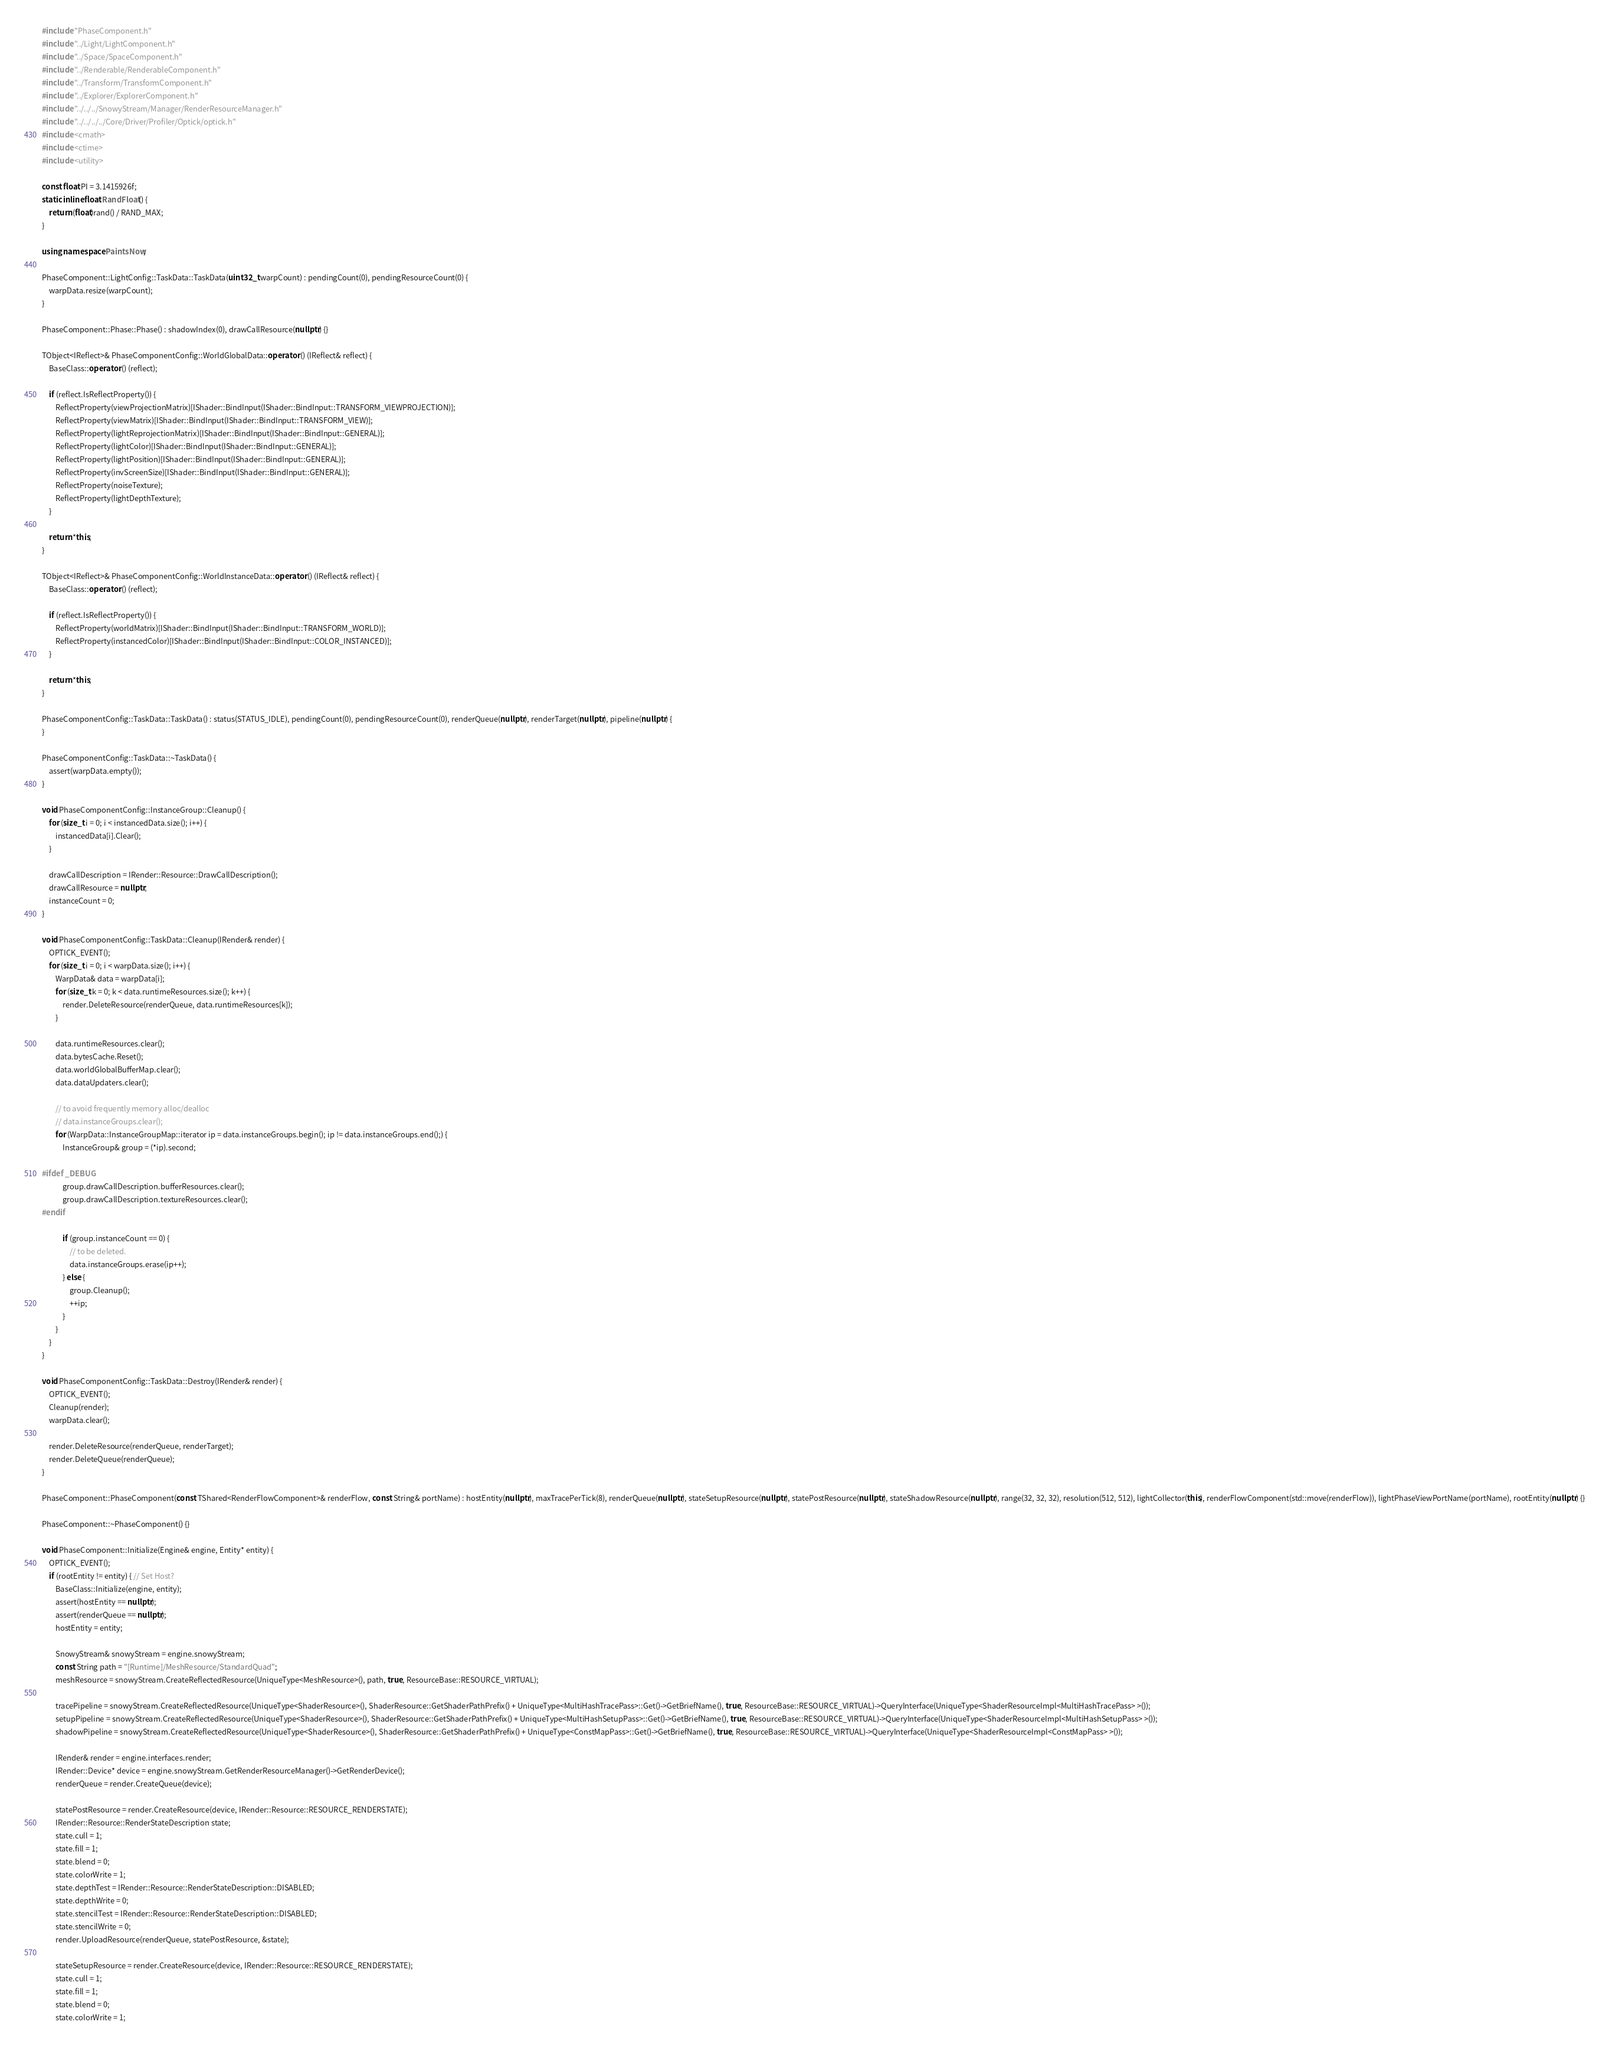Convert code to text. <code><loc_0><loc_0><loc_500><loc_500><_C++_>#include "PhaseComponent.h"
#include "../Light/LightComponent.h"
#include "../Space/SpaceComponent.h"
#include "../Renderable/RenderableComponent.h"
#include "../Transform/TransformComponent.h"
#include "../Explorer/ExplorerComponent.h"
#include "../../../SnowyStream/Manager/RenderResourceManager.h"
#include "../../../../Core/Driver/Profiler/Optick/optick.h"
#include <cmath>
#include <ctime>
#include <utility>

const float PI = 3.1415926f;
static inline float RandFloat() {
	return (float)rand() / RAND_MAX;
}

using namespace PaintsNow;

PhaseComponent::LightConfig::TaskData::TaskData(uint32_t warpCount) : pendingCount(0), pendingResourceCount(0) {
	warpData.resize(warpCount);
}

PhaseComponent::Phase::Phase() : shadowIndex(0), drawCallResource(nullptr) {}

TObject<IReflect>& PhaseComponentConfig::WorldGlobalData::operator () (IReflect& reflect) {
	BaseClass::operator () (reflect);

	if (reflect.IsReflectProperty()) {
		ReflectProperty(viewProjectionMatrix)[IShader::BindInput(IShader::BindInput::TRANSFORM_VIEWPROJECTION)];
		ReflectProperty(viewMatrix)[IShader::BindInput(IShader::BindInput::TRANSFORM_VIEW)];
		ReflectProperty(lightReprojectionMatrix)[IShader::BindInput(IShader::BindInput::GENERAL)];
		ReflectProperty(lightColor)[IShader::BindInput(IShader::BindInput::GENERAL)];
		ReflectProperty(lightPosition)[IShader::BindInput(IShader::BindInput::GENERAL)];
		ReflectProperty(invScreenSize)[IShader::BindInput(IShader::BindInput::GENERAL)];
		ReflectProperty(noiseTexture);
		ReflectProperty(lightDepthTexture);
	}

	return *this;
}

TObject<IReflect>& PhaseComponentConfig::WorldInstanceData::operator () (IReflect& reflect) {
	BaseClass::operator () (reflect);

	if (reflect.IsReflectProperty()) {
		ReflectProperty(worldMatrix)[IShader::BindInput(IShader::BindInput::TRANSFORM_WORLD)];
		ReflectProperty(instancedColor)[IShader::BindInput(IShader::BindInput::COLOR_INSTANCED)];
	}

	return *this;
}

PhaseComponentConfig::TaskData::TaskData() : status(STATUS_IDLE), pendingCount(0), pendingResourceCount(0), renderQueue(nullptr), renderTarget(nullptr), pipeline(nullptr) {
}

PhaseComponentConfig::TaskData::~TaskData() {
	assert(warpData.empty());
}

void PhaseComponentConfig::InstanceGroup::Cleanup() {
	for (size_t i = 0; i < instancedData.size(); i++) {
		instancedData[i].Clear();
	}

	drawCallDescription = IRender::Resource::DrawCallDescription();
	drawCallResource = nullptr;
	instanceCount = 0;
}

void PhaseComponentConfig::TaskData::Cleanup(IRender& render) {
	OPTICK_EVENT();
	for (size_t i = 0; i < warpData.size(); i++) {
		WarpData& data = warpData[i];
		for (size_t k = 0; k < data.runtimeResources.size(); k++) {
			render.DeleteResource(renderQueue, data.runtimeResources[k]);
		}

		data.runtimeResources.clear();
		data.bytesCache.Reset();
		data.worldGlobalBufferMap.clear();
		data.dataUpdaters.clear();

		// to avoid frequently memory alloc/dealloc
		// data.instanceGroups.clear();
		for (WarpData::InstanceGroupMap::iterator ip = data.instanceGroups.begin(); ip != data.instanceGroups.end();) {
			InstanceGroup& group = (*ip).second;

#ifdef _DEBUG
			group.drawCallDescription.bufferResources.clear();
			group.drawCallDescription.textureResources.clear();
#endif

			if (group.instanceCount == 0) {
				// to be deleted.
				data.instanceGroups.erase(ip++);
			} else {
				group.Cleanup();
				++ip;
			}
		}
	}
}

void PhaseComponentConfig::TaskData::Destroy(IRender& render) {
	OPTICK_EVENT();
	Cleanup(render);
	warpData.clear();

	render.DeleteResource(renderQueue, renderTarget);
	render.DeleteQueue(renderQueue);
}

PhaseComponent::PhaseComponent(const TShared<RenderFlowComponent>& renderFlow, const String& portName) : hostEntity(nullptr), maxTracePerTick(8), renderQueue(nullptr), stateSetupResource(nullptr), statePostResource(nullptr), stateShadowResource(nullptr), range(32, 32, 32), resolution(512, 512), lightCollector(this), renderFlowComponent(std::move(renderFlow)), lightPhaseViewPortName(portName), rootEntity(nullptr) {}

PhaseComponent::~PhaseComponent() {}

void PhaseComponent::Initialize(Engine& engine, Entity* entity) {
	OPTICK_EVENT();
	if (rootEntity != entity) { // Set Host?
		BaseClass::Initialize(engine, entity);
		assert(hostEntity == nullptr);
		assert(renderQueue == nullptr);
		hostEntity = entity;

		SnowyStream& snowyStream = engine.snowyStream;
		const String path = "[Runtime]/MeshResource/StandardQuad";
		meshResource = snowyStream.CreateReflectedResource(UniqueType<MeshResource>(), path, true, ResourceBase::RESOURCE_VIRTUAL);

		tracePipeline = snowyStream.CreateReflectedResource(UniqueType<ShaderResource>(), ShaderResource::GetShaderPathPrefix() + UniqueType<MultiHashTracePass>::Get()->GetBriefName(), true, ResourceBase::RESOURCE_VIRTUAL)->QueryInterface(UniqueType<ShaderResourceImpl<MultiHashTracePass> >());
		setupPipeline = snowyStream.CreateReflectedResource(UniqueType<ShaderResource>(), ShaderResource::GetShaderPathPrefix() + UniqueType<MultiHashSetupPass>::Get()->GetBriefName(), true, ResourceBase::RESOURCE_VIRTUAL)->QueryInterface(UniqueType<ShaderResourceImpl<MultiHashSetupPass> >());
		shadowPipeline = snowyStream.CreateReflectedResource(UniqueType<ShaderResource>(), ShaderResource::GetShaderPathPrefix() + UniqueType<ConstMapPass>::Get()->GetBriefName(), true, ResourceBase::RESOURCE_VIRTUAL)->QueryInterface(UniqueType<ShaderResourceImpl<ConstMapPass> >());

		IRender& render = engine.interfaces.render;
		IRender::Device* device = engine.snowyStream.GetRenderResourceManager()->GetRenderDevice();
		renderQueue = render.CreateQueue(device);

		statePostResource = render.CreateResource(device, IRender::Resource::RESOURCE_RENDERSTATE);
		IRender::Resource::RenderStateDescription state;
		state.cull = 1;
		state.fill = 1;
		state.blend = 0;
		state.colorWrite = 1;
		state.depthTest = IRender::Resource::RenderStateDescription::DISABLED;
		state.depthWrite = 0;
		state.stencilTest = IRender::Resource::RenderStateDescription::DISABLED;
		state.stencilWrite = 0;
		render.UploadResource(renderQueue, statePostResource, &state);

		stateSetupResource = render.CreateResource(device, IRender::Resource::RESOURCE_RENDERSTATE);
		state.cull = 1;
		state.fill = 1;
		state.blend = 0;
		state.colorWrite = 1;</code> 